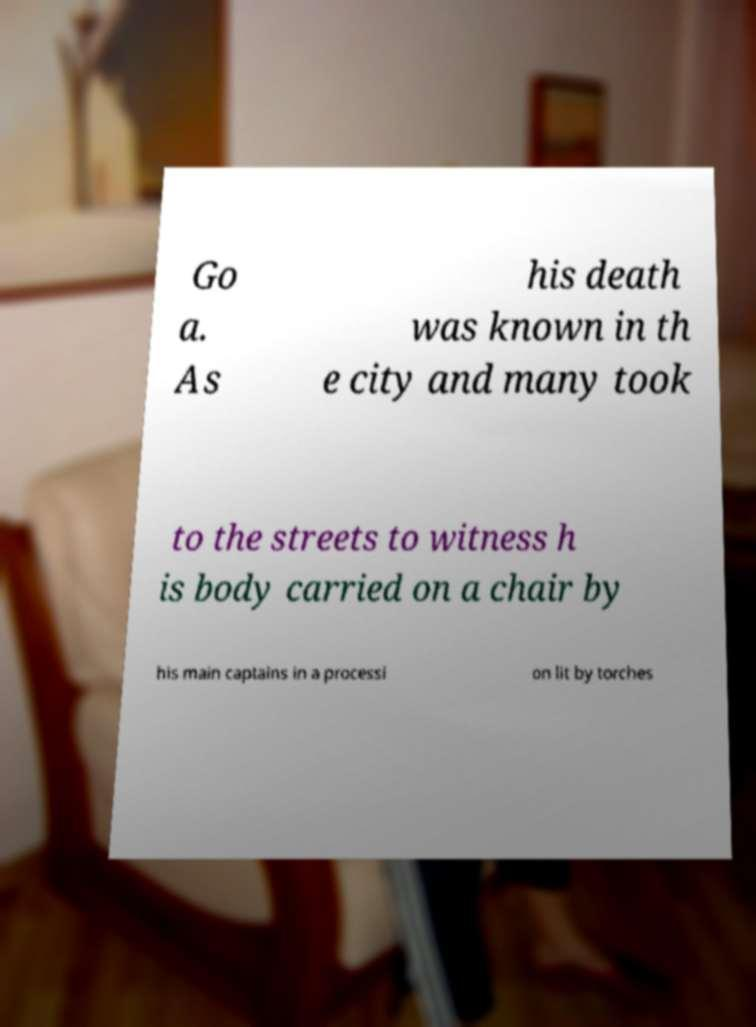There's text embedded in this image that I need extracted. Can you transcribe it verbatim? Go a. As his death was known in th e city and many took to the streets to witness h is body carried on a chair by his main captains in a processi on lit by torches 